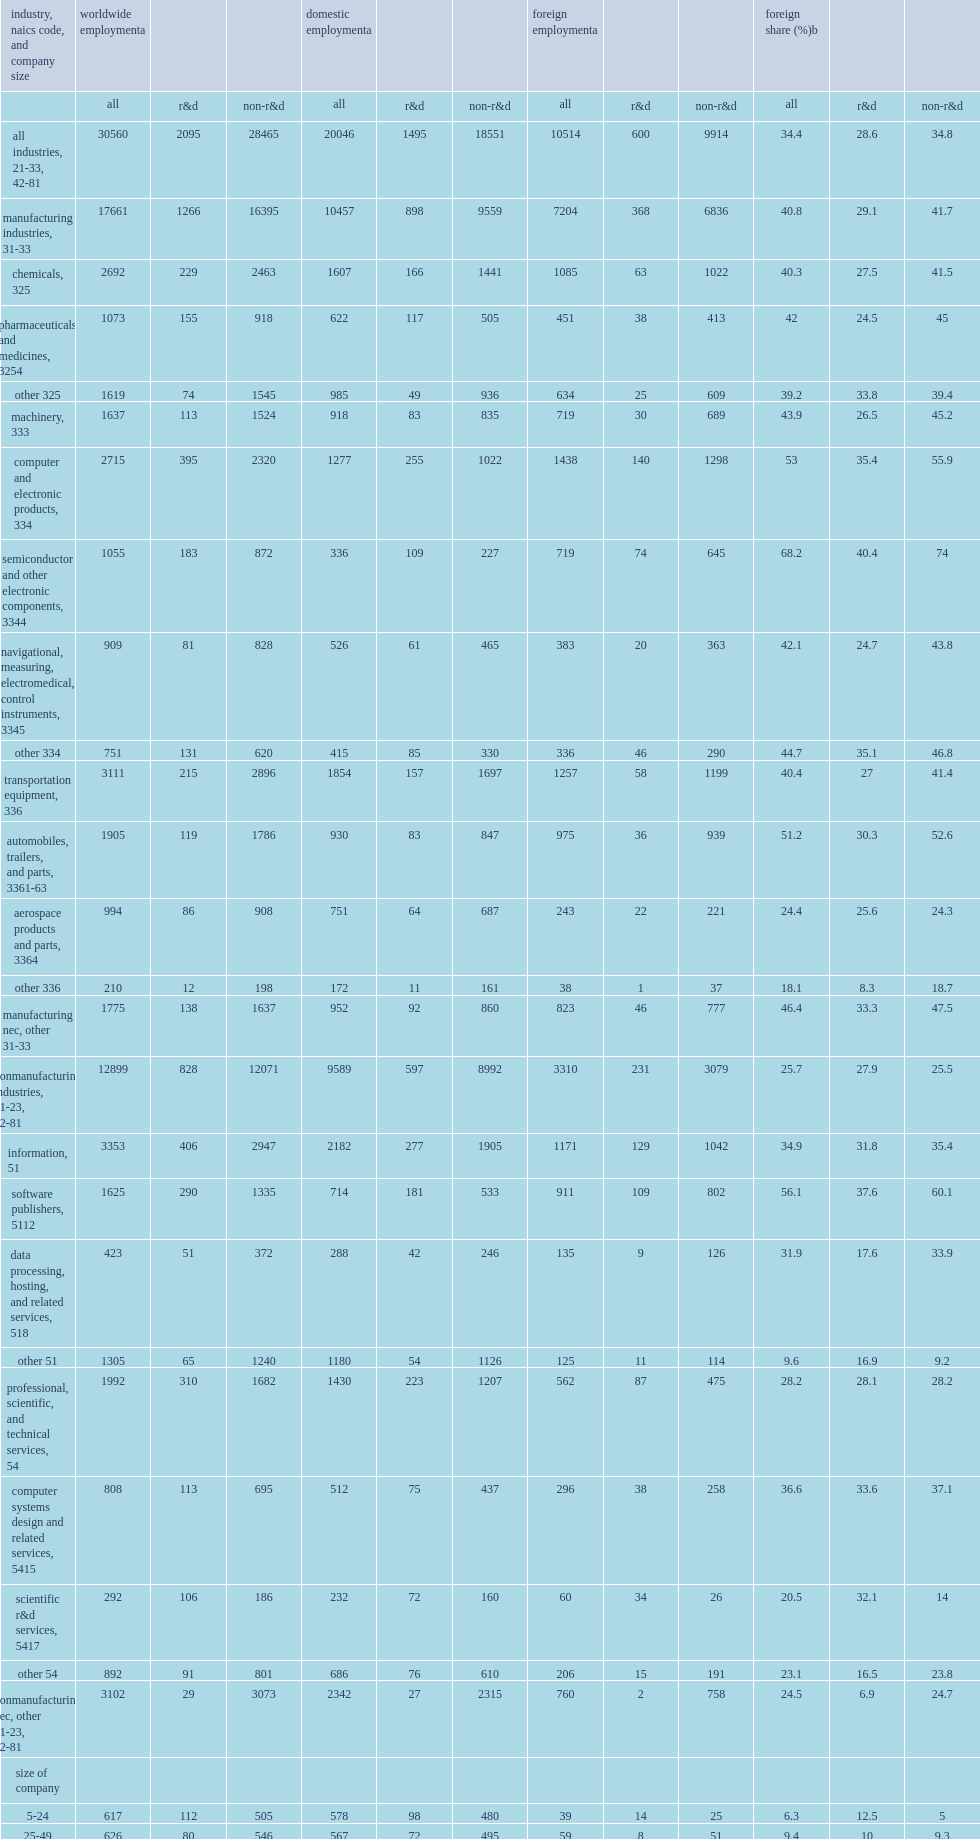How many thousand r&d workers did companies active in research and development (those that paid for or performed r&d) employ in the united states in 2013? 1495.0. How many percent did companies with 500 or more domestic employees account of the 1.5 million business r&d employees in the united states in 2013? 0.697659. 